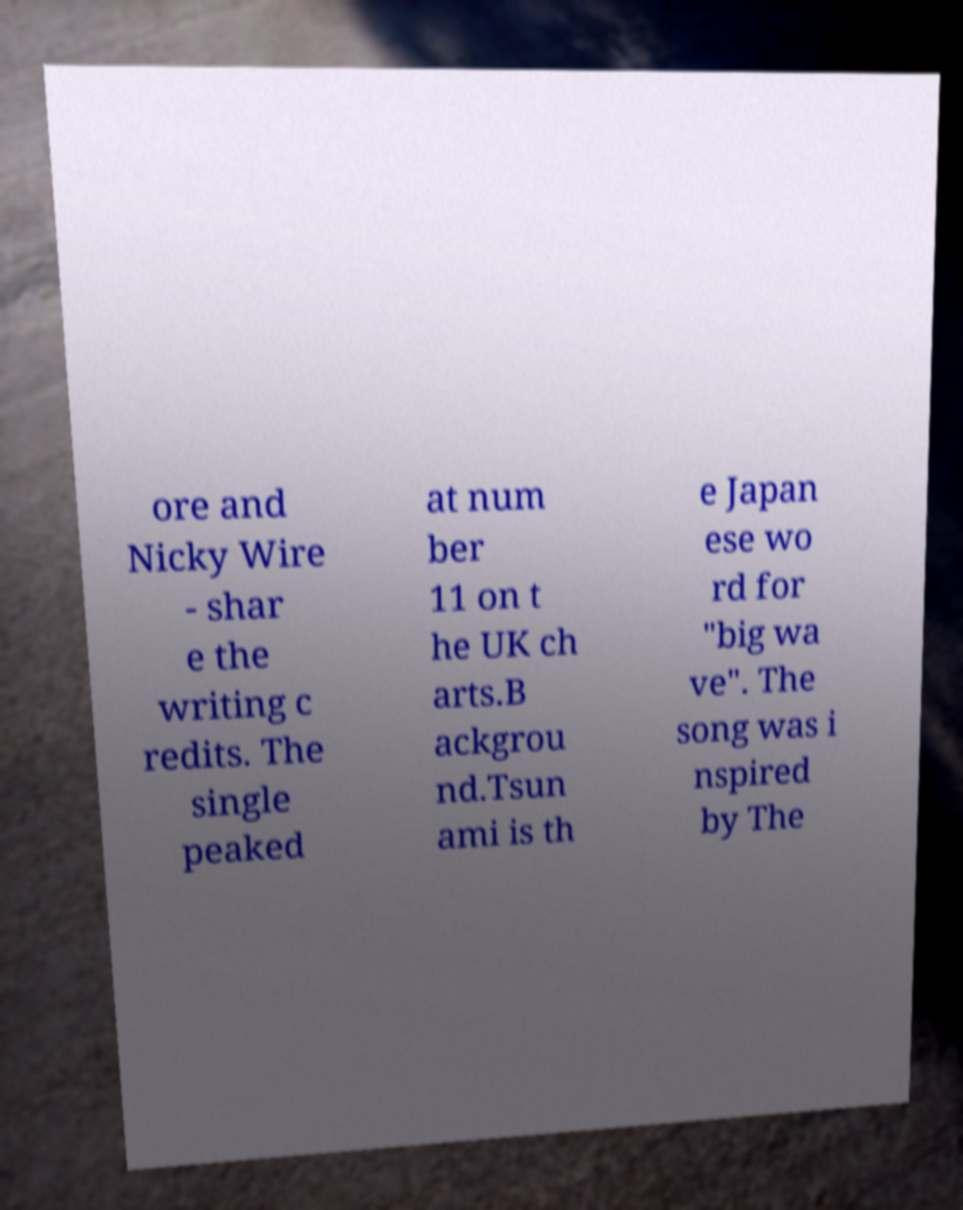Could you assist in decoding the text presented in this image and type it out clearly? ore and Nicky Wire - shar e the writing c redits. The single peaked at num ber 11 on t he UK ch arts.B ackgrou nd.Tsun ami is th e Japan ese wo rd for "big wa ve". The song was i nspired by The 